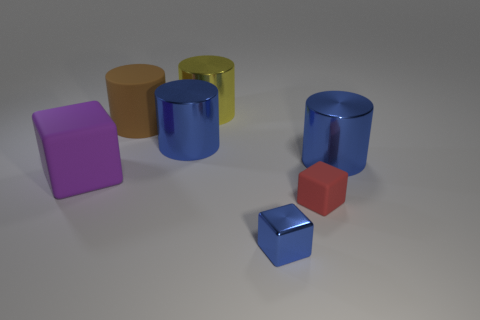There is another red object that is the same shape as the tiny metallic thing; what is its size?
Provide a short and direct response. Small. What is the material of the large blue thing in front of the big blue object behind the thing to the right of the tiny red matte thing?
Give a very brief answer. Metal. There is a metal object in front of the shiny cylinder that is to the right of the tiny red cube; what is its size?
Provide a short and direct response. Small. What is the color of the other matte thing that is the same shape as the red rubber object?
Your answer should be very brief. Purple. How many other shiny objects have the same color as the tiny shiny thing?
Offer a terse response. 2. Do the yellow metallic cylinder and the red rubber block have the same size?
Ensure brevity in your answer.  No. What is the tiny blue block made of?
Provide a succinct answer. Metal. There is a tiny object that is made of the same material as the purple cube; what color is it?
Your response must be concise. Red. Is the big purple cube made of the same material as the big brown thing behind the big purple cube?
Ensure brevity in your answer.  Yes. How many big cubes have the same material as the tiny blue thing?
Give a very brief answer. 0. 